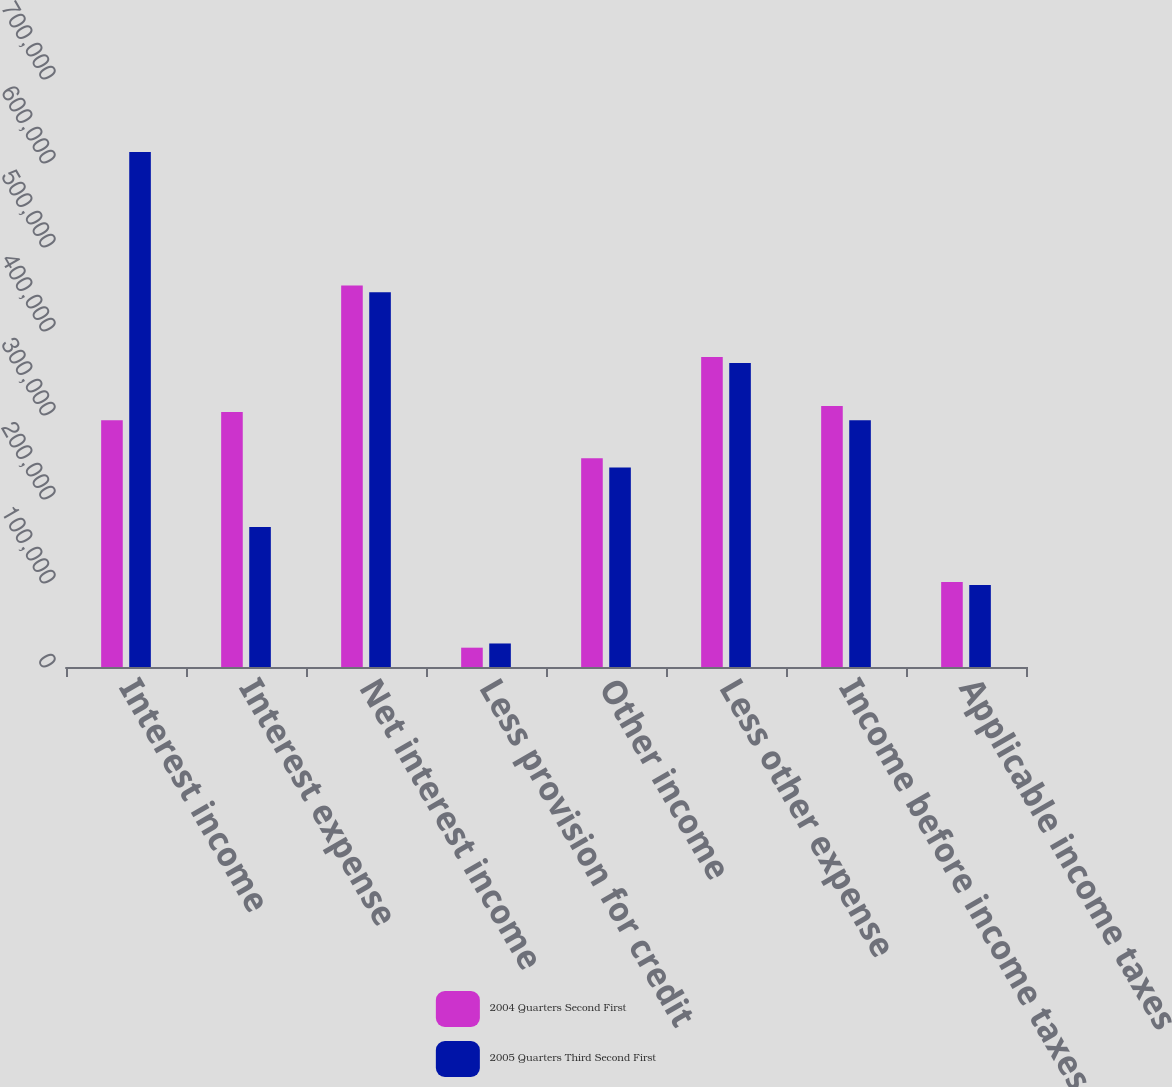Convert chart to OTSL. <chart><loc_0><loc_0><loc_500><loc_500><stacked_bar_chart><ecel><fcel>Interest income<fcel>Interest expense<fcel>Net interest income<fcel>Less provision for credit<fcel>Other income<fcel>Less other expense<fcel>Income before income taxes<fcel>Applicable income taxes<nl><fcel>2004 Quarters Second First<fcel>293894<fcel>303493<fcel>454161<fcel>23000<fcel>248604<fcel>369114<fcel>310651<fcel>101113<nl><fcel>2005 Quarters Third Second First<fcel>613012<fcel>166755<fcel>446257<fcel>28000<fcel>237559<fcel>361922<fcel>293894<fcel>97624<nl></chart> 